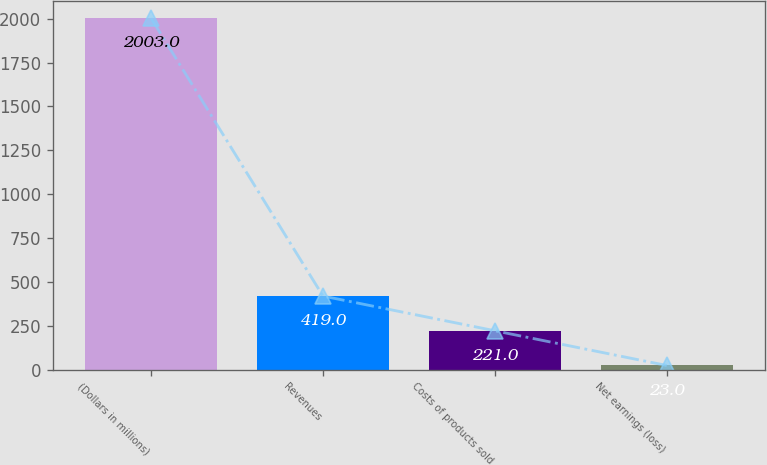<chart> <loc_0><loc_0><loc_500><loc_500><bar_chart><fcel>(Dollars in millions)<fcel>Revenues<fcel>Costs of products sold<fcel>Net earnings (loss)<nl><fcel>2003<fcel>419<fcel>221<fcel>23<nl></chart> 